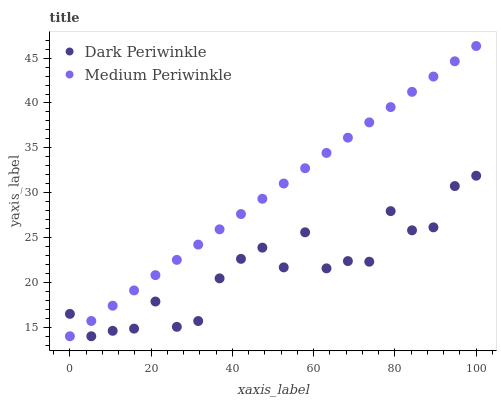Does Dark Periwinkle have the minimum area under the curve?
Answer yes or no. Yes. Does Medium Periwinkle have the maximum area under the curve?
Answer yes or no. Yes. Does Dark Periwinkle have the maximum area under the curve?
Answer yes or no. No. Is Medium Periwinkle the smoothest?
Answer yes or no. Yes. Is Dark Periwinkle the roughest?
Answer yes or no. Yes. Is Dark Periwinkle the smoothest?
Answer yes or no. No. Does Medium Periwinkle have the lowest value?
Answer yes or no. Yes. Does Medium Periwinkle have the highest value?
Answer yes or no. Yes. Does Dark Periwinkle have the highest value?
Answer yes or no. No. Does Medium Periwinkle intersect Dark Periwinkle?
Answer yes or no. Yes. Is Medium Periwinkle less than Dark Periwinkle?
Answer yes or no. No. Is Medium Periwinkle greater than Dark Periwinkle?
Answer yes or no. No. 